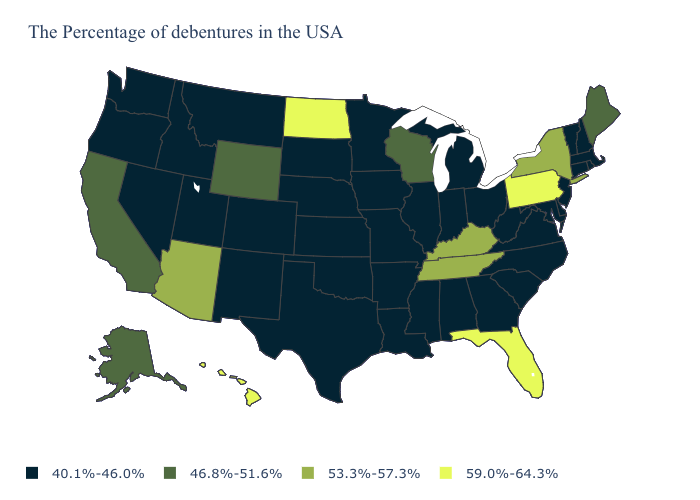What is the highest value in the USA?
Answer briefly. 59.0%-64.3%. Name the states that have a value in the range 40.1%-46.0%?
Quick response, please. Massachusetts, Rhode Island, New Hampshire, Vermont, Connecticut, New Jersey, Delaware, Maryland, Virginia, North Carolina, South Carolina, West Virginia, Ohio, Georgia, Michigan, Indiana, Alabama, Illinois, Mississippi, Louisiana, Missouri, Arkansas, Minnesota, Iowa, Kansas, Nebraska, Oklahoma, Texas, South Dakota, Colorado, New Mexico, Utah, Montana, Idaho, Nevada, Washington, Oregon. Among the states that border California , does Oregon have the highest value?
Answer briefly. No. Which states have the lowest value in the USA?
Answer briefly. Massachusetts, Rhode Island, New Hampshire, Vermont, Connecticut, New Jersey, Delaware, Maryland, Virginia, North Carolina, South Carolina, West Virginia, Ohio, Georgia, Michigan, Indiana, Alabama, Illinois, Mississippi, Louisiana, Missouri, Arkansas, Minnesota, Iowa, Kansas, Nebraska, Oklahoma, Texas, South Dakota, Colorado, New Mexico, Utah, Montana, Idaho, Nevada, Washington, Oregon. What is the value of North Dakota?
Short answer required. 59.0%-64.3%. Does Tennessee have a lower value than Florida?
Quick response, please. Yes. Does the first symbol in the legend represent the smallest category?
Concise answer only. Yes. Name the states that have a value in the range 46.8%-51.6%?
Quick response, please. Maine, Wisconsin, Wyoming, California, Alaska. What is the value of West Virginia?
Concise answer only. 40.1%-46.0%. Which states have the highest value in the USA?
Short answer required. Pennsylvania, Florida, North Dakota, Hawaii. What is the value of Mississippi?
Answer briefly. 40.1%-46.0%. Among the states that border Alabama , which have the highest value?
Write a very short answer. Florida. Which states have the highest value in the USA?
Concise answer only. Pennsylvania, Florida, North Dakota, Hawaii. Is the legend a continuous bar?
Write a very short answer. No. 